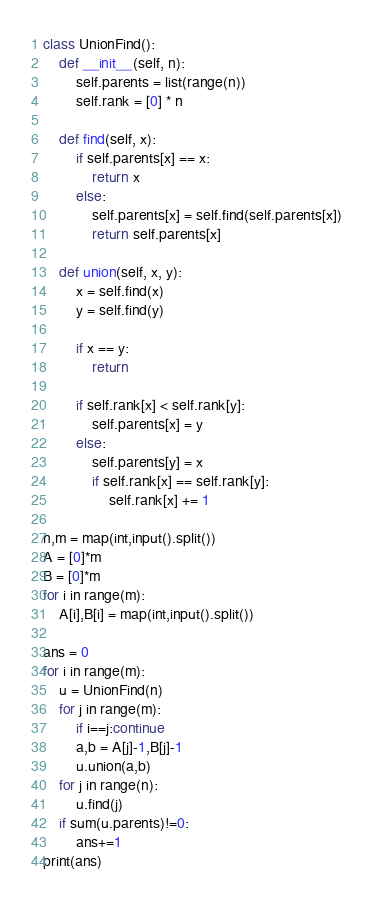<code> <loc_0><loc_0><loc_500><loc_500><_Python_>class UnionFind():
    def __init__(self, n):
        self.parents = list(range(n))
        self.rank = [0] * n

    def find(self, x):
        if self.parents[x] == x:
            return x
        else:
            self.parents[x] = self.find(self.parents[x])
            return self.parents[x]

    def union(self, x, y):
        x = self.find(x)
        y = self.find(y)

        if x == y:
            return

        if self.rank[x] < self.rank[y]:
            self.parents[x] = y
        else:
            self.parents[y] = x
            if self.rank[x] == self.rank[y]:
                self.rank[x] += 1

n,m = map(int,input().split())
A = [0]*m
B = [0]*m
for i in range(m):
    A[i],B[i] = map(int,input().split())

ans = 0
for i in range(m):
    u = UnionFind(n)
    for j in range(m):
        if i==j:continue
        a,b = A[j]-1,B[j]-1
        u.union(a,b)
    for j in range(n):
        u.find(j)
    if sum(u.parents)!=0:
        ans+=1
print(ans)



</code> 